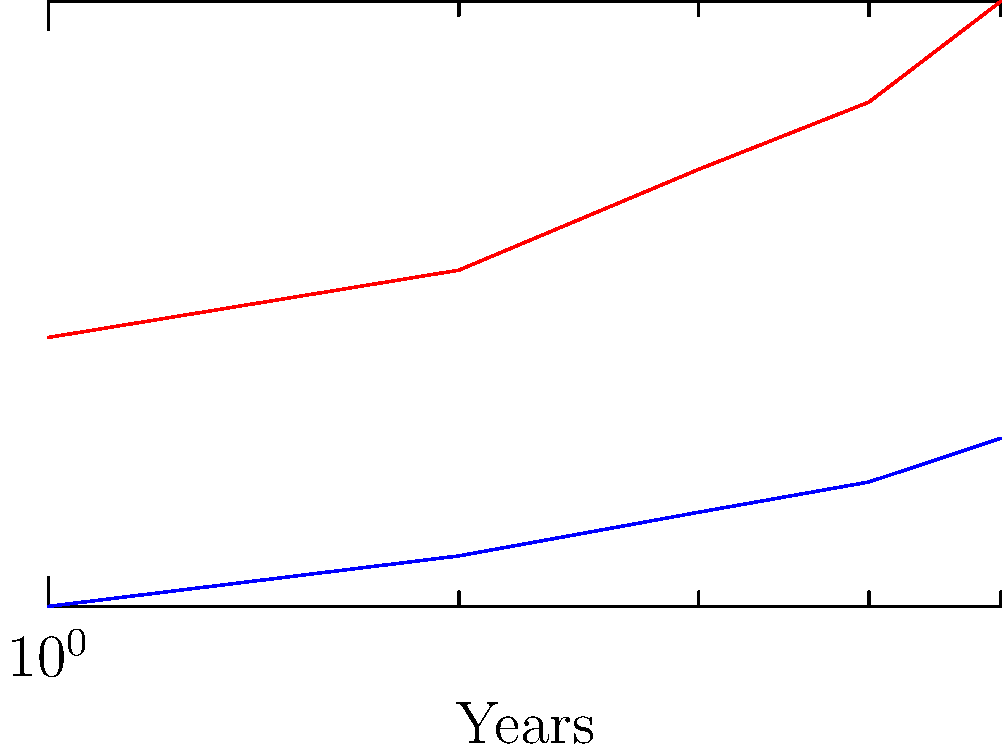Analyze the dual-axis chart showing a company's R&D spending and profit margins over five years. What is the relationship between R&D spending and profit margins, and what might this imply about the company's financial strategy? To analyze the relationship between R&D spending and profit margins:

1. Observe the trends:
   - R&D spending (blue line) increases steadily from $2 billion to $7 billion over 5 years.
   - Profit margins (red line) also increase from 10% to 20% over the same period.

2. Calculate growth rates:
   - R&D spending growth: $(7 - 2) / 2 * 100\% = 250\%$
   - Profit margin growth: $(20\% - 10\%) / 10\% * 100\% = 100\%$

3. Analyze the relationship:
   - Both metrics show positive growth, indicating a positive correlation.
   - R&D spending grows faster than profit margins (250% vs. 100%).

4. Interpret the implications:
   - The company is investing heavily in R&D, which appears to be paying off with increased profit margins.
   - The strategy suggests a focus on innovation and long-term growth.
   - However, the slower growth in profit margins compared to R&D spending might indicate diminishing returns or a lag in realizing benefits from R&D investments.

5. Consider financial strategy:
   - The company seems willing to allocate significant resources to R&D, betting on future innovations to drive profitability.
   - This approach may be suitable for industries where technological advancement is crucial for maintaining competitiveness.
Answer: Positive correlation; increased R&D spending likely driving profit growth, indicating innovation-focused strategy with potential long-term benefits. 